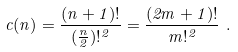Convert formula to latex. <formula><loc_0><loc_0><loc_500><loc_500>c ( n ) = \frac { ( n + 1 ) ! } { ( \frac { n } { 2 } ) ! ^ { 2 } } = \frac { ( 2 m + 1 ) ! } { m ! ^ { 2 } } \ .</formula> 